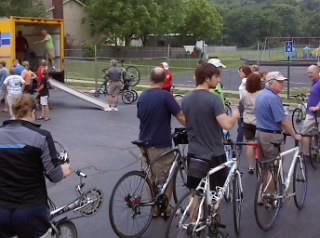Why might these people be lined up? bike race 